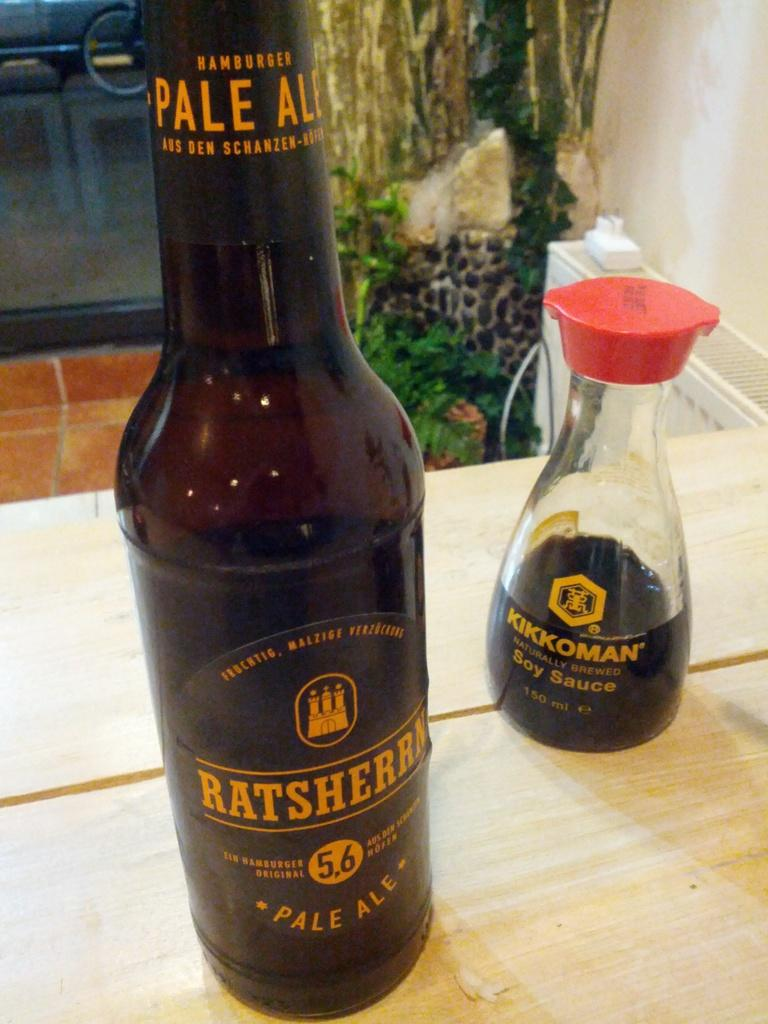<image>
Render a clear and concise summary of the photo. A container of Kikkoman Soy Sauce sits on a table next to a beer bottle. 